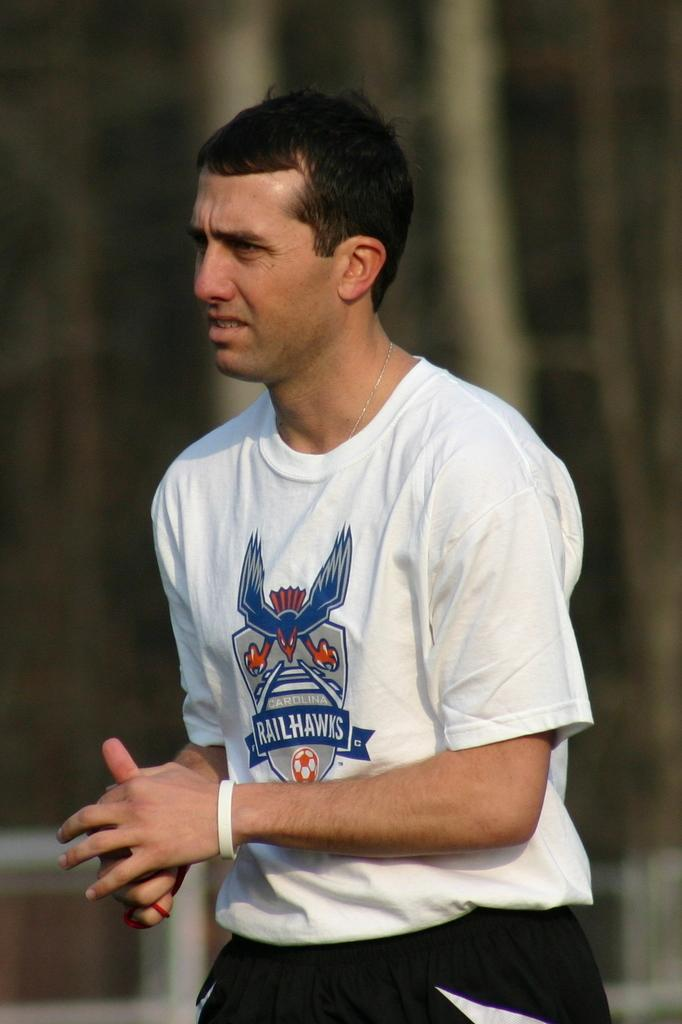<image>
Write a terse but informative summary of the picture. A white man with brown hair wearing a Carolina Railhawks white tshirt. 